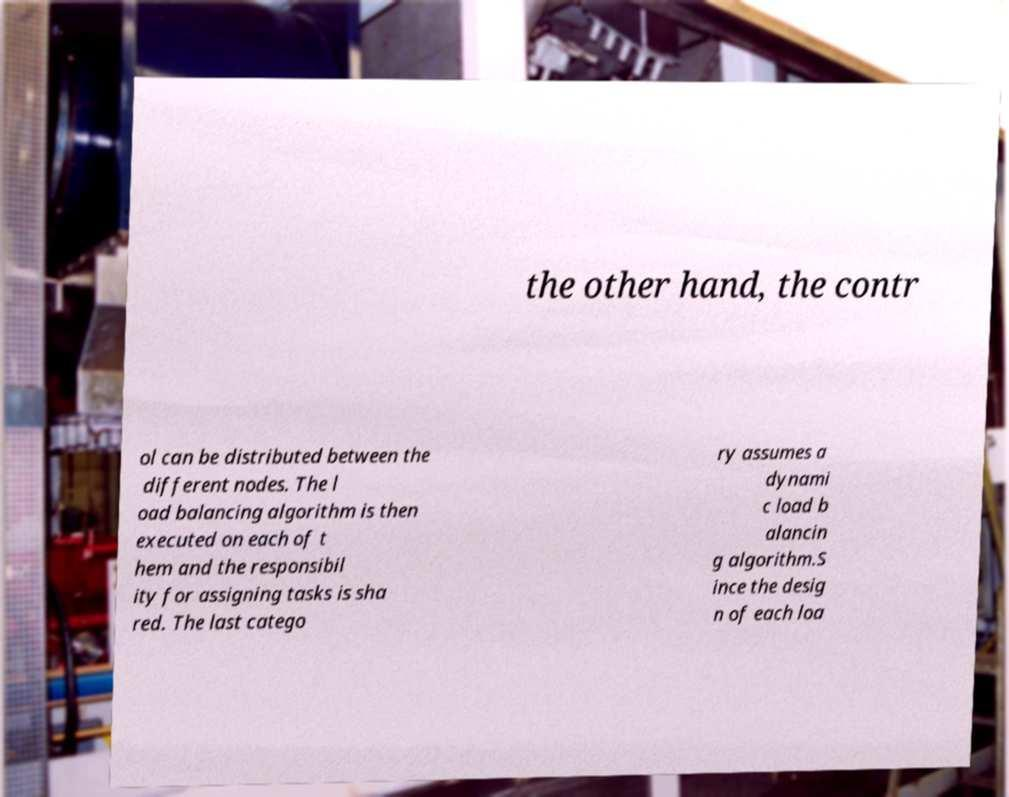There's text embedded in this image that I need extracted. Can you transcribe it verbatim? the other hand, the contr ol can be distributed between the different nodes. The l oad balancing algorithm is then executed on each of t hem and the responsibil ity for assigning tasks is sha red. The last catego ry assumes a dynami c load b alancin g algorithm.S ince the desig n of each loa 